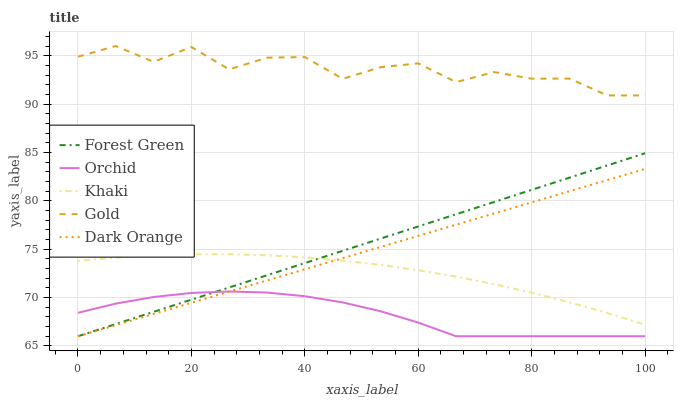Does Orchid have the minimum area under the curve?
Answer yes or no. Yes. Does Gold have the maximum area under the curve?
Answer yes or no. Yes. Does Forest Green have the minimum area under the curve?
Answer yes or no. No. Does Forest Green have the maximum area under the curve?
Answer yes or no. No. Is Dark Orange the smoothest?
Answer yes or no. Yes. Is Gold the roughest?
Answer yes or no. Yes. Is Forest Green the smoothest?
Answer yes or no. No. Is Forest Green the roughest?
Answer yes or no. No. Does Dark Orange have the lowest value?
Answer yes or no. Yes. Does Khaki have the lowest value?
Answer yes or no. No. Does Gold have the highest value?
Answer yes or no. Yes. Does Forest Green have the highest value?
Answer yes or no. No. Is Khaki less than Gold?
Answer yes or no. Yes. Is Gold greater than Orchid?
Answer yes or no. Yes. Does Khaki intersect Dark Orange?
Answer yes or no. Yes. Is Khaki less than Dark Orange?
Answer yes or no. No. Is Khaki greater than Dark Orange?
Answer yes or no. No. Does Khaki intersect Gold?
Answer yes or no. No. 